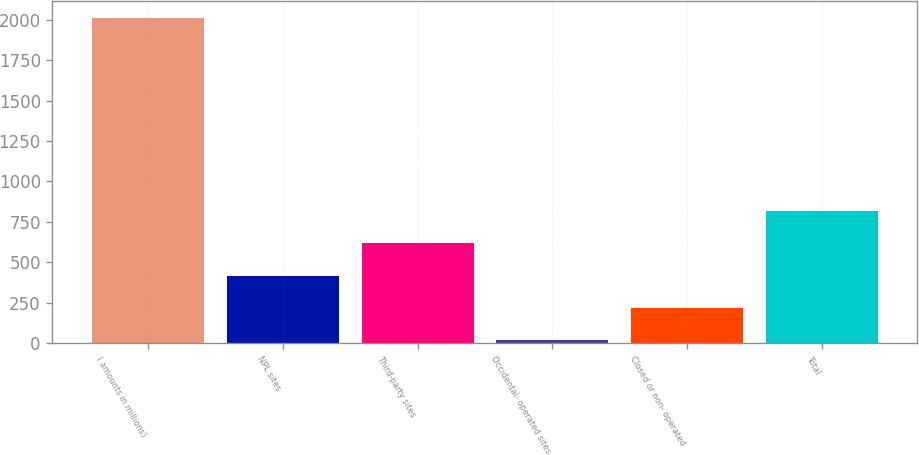Convert chart. <chart><loc_0><loc_0><loc_500><loc_500><bar_chart><fcel>( amounts in millions)<fcel>NPL sites<fcel>Third-party sites<fcel>Occidental- operated sites<fcel>Closed or non- operated<fcel>Total<nl><fcel>2015<fcel>417.4<fcel>617.1<fcel>18<fcel>217.7<fcel>816.8<nl></chart> 